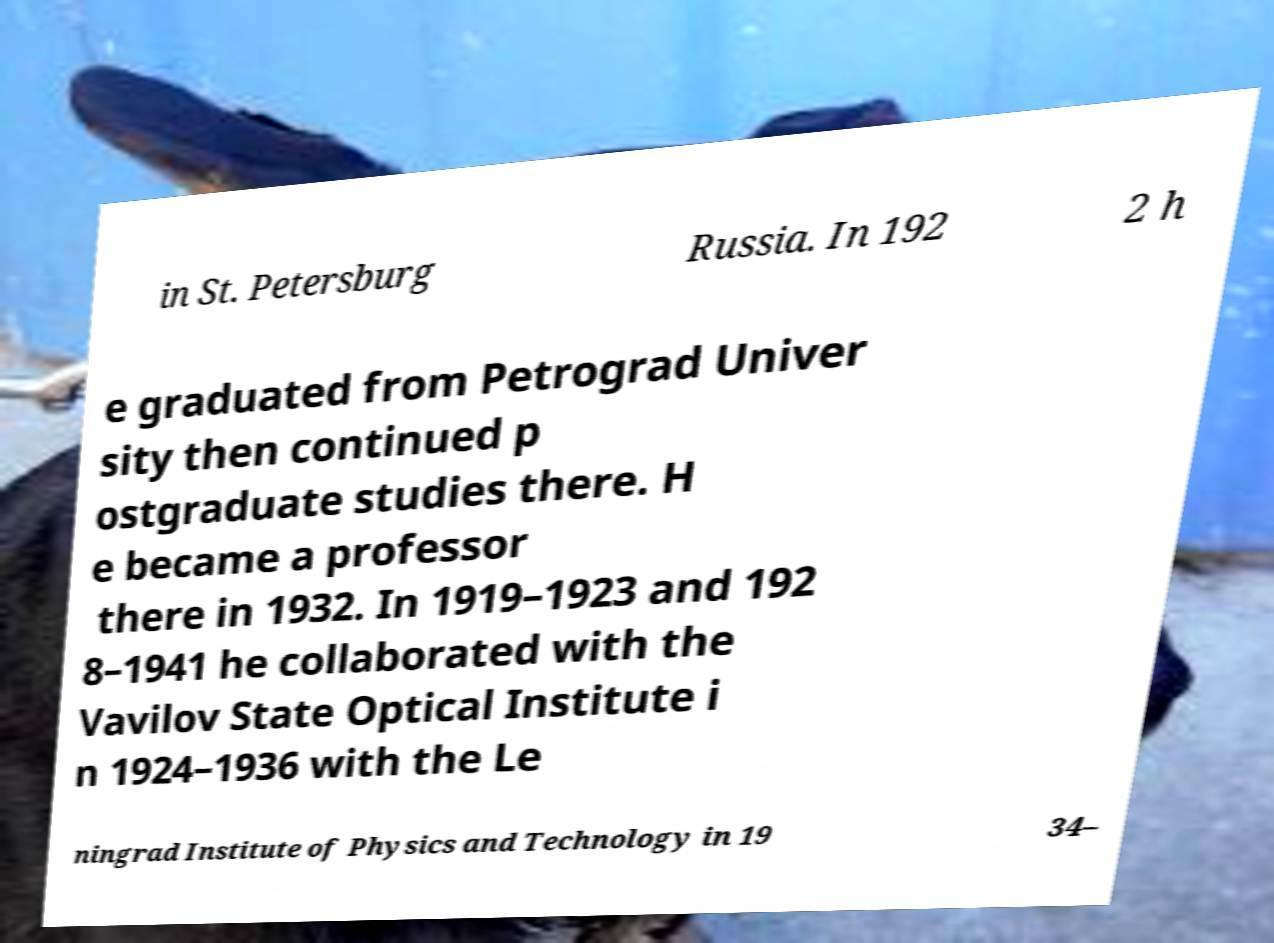There's text embedded in this image that I need extracted. Can you transcribe it verbatim? in St. Petersburg Russia. In 192 2 h e graduated from Petrograd Univer sity then continued p ostgraduate studies there. H e became a professor there in 1932. In 1919–1923 and 192 8–1941 he collaborated with the Vavilov State Optical Institute i n 1924–1936 with the Le ningrad Institute of Physics and Technology in 19 34– 